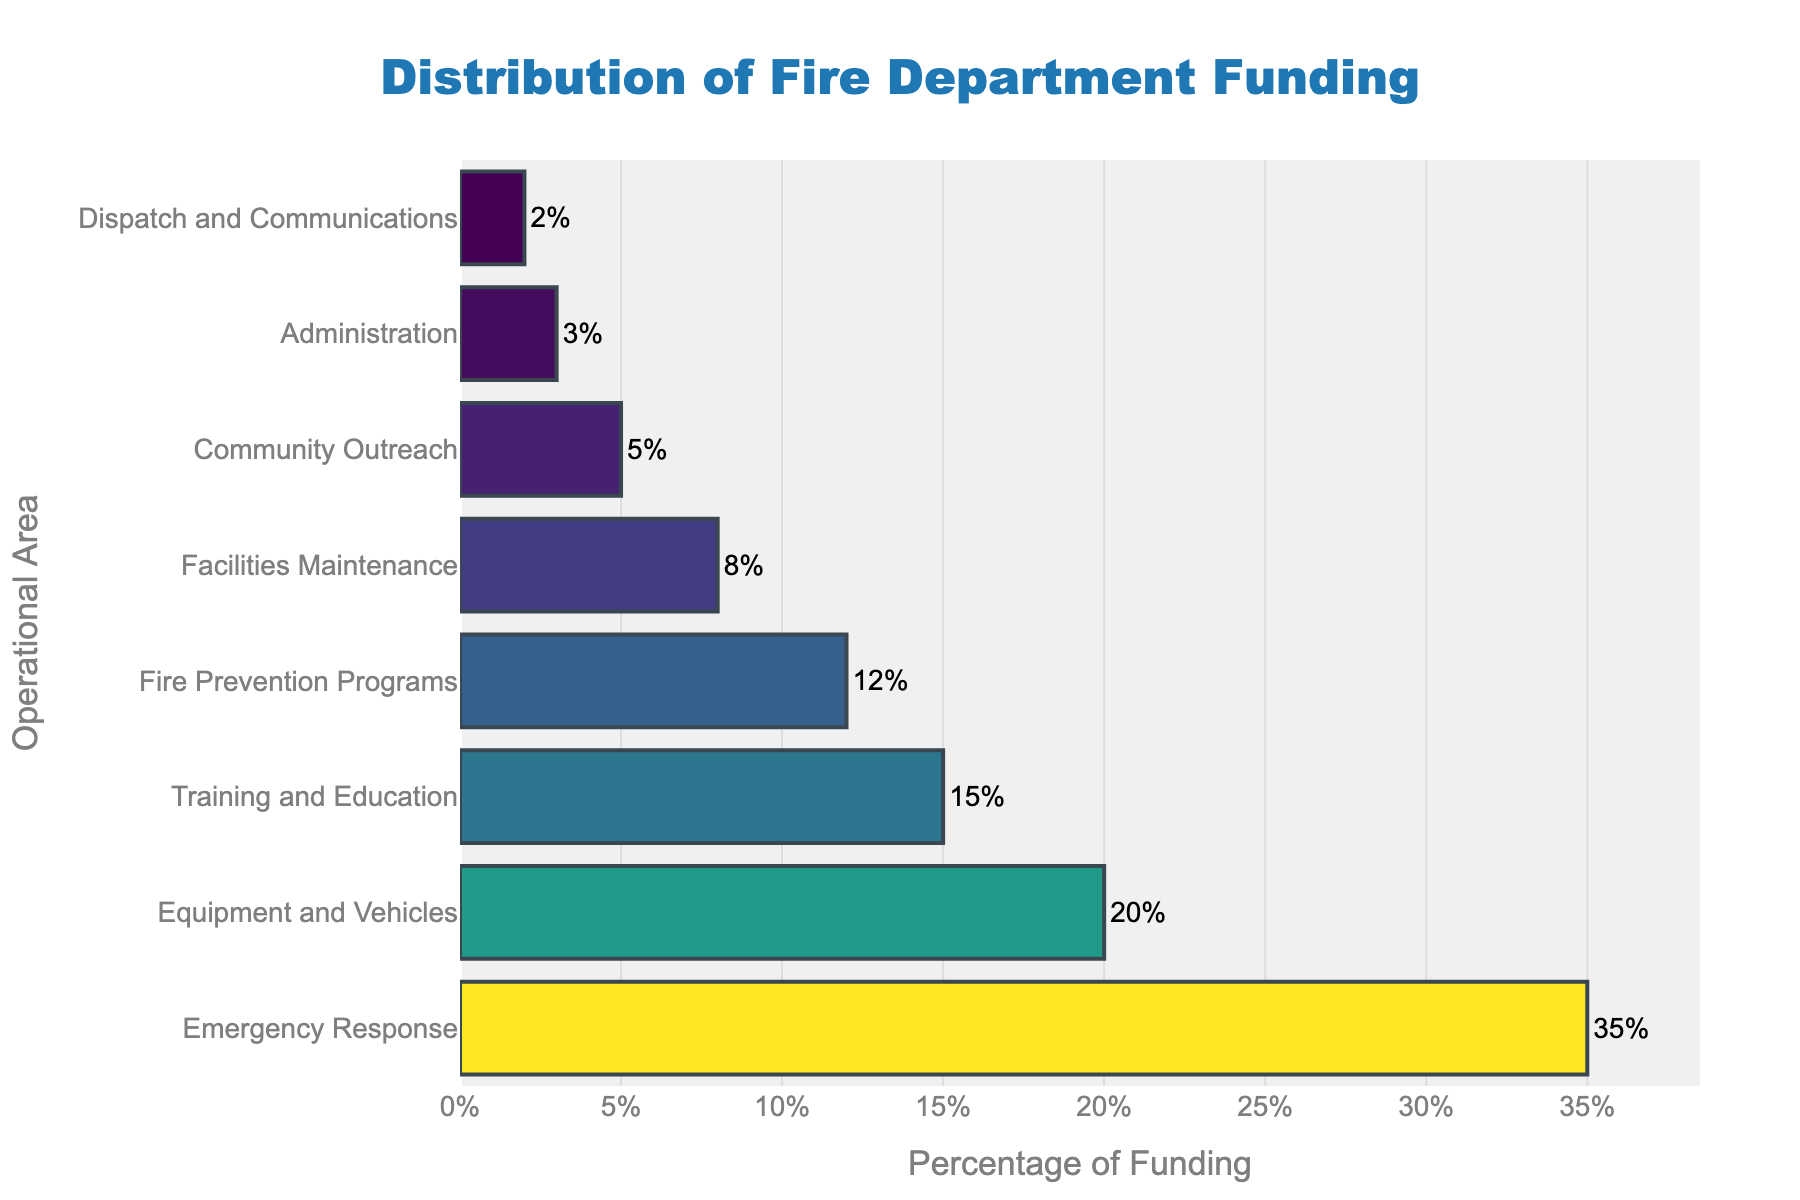Which operational area receives the most funding? The bar for Emergency Response is the longest and shows a percentage of 35%.
Answer: Emergency Response What's the combined percentage of funding for Training and Education and Fire Prevention Programs? The percentage for Training and Education is 15% and for Fire Prevention Programs is 12%. Adding these together gives 15% + 12% = 27%.
Answer: 27% How does the funding for Equipment and Vehicles compare to Facilities Maintenance? The bar for Equipment and Vehicles is longer than the bar for Facilities Maintenance. The percentage for Equipment and Vehicles is 20%, whereas it is 8% for Facilities Maintenance.
Answer: Equipment and Vehicles receives more funding Which operational area has the least funding, and what is its percentage? The shortest bar represents Dispatch and Communications, which has a percentage of 2%.
Answer: Dispatch and Communications, 2% Is the percentage of funding for Community Outreach greater than or equal to that for Administration? The percentage of funding for Community Outreach is 5%, which is greater than the 3% for Administration.
Answer: Yes What’s the difference in funding percentage between Emergency Response and Community Outreach? The percentage for Emergency Response is 35% and for Community Outreach is 5%. The difference is 35% - 5% = 30%.
Answer: 30% What is the average percentage of funding for the areas that receive at least 10% of the funding? The areas are: Emergency Response (35%), Equipment and Vehicles (20%), Training and Education (15%), and Fire Prevention Programs (12%). The sum is 35% + 20% + 15% + 12% = 82%. There are 4 areas, so the average is 82% / 4 = 20.5%.
Answer: 20.5% Does the sum of the percentages for Facilities Maintenance and Administration equal the percentage for Training and Education? Facilities Maintenance is 8% and Administration is 3%. The sum is 8% + 3% = 11%, which is less than the 15% for Training and Education.
Answer: No Which area has a lower percentage of funding – Community Outreach or Dispatch and Communications? Comparing the percentages, Community Outreach has 5% and Dispatch and Communications has 2%.
Answer: Dispatch and Communications What is the total percentage of funding allocated to operational areas receiving less than 10% each? The areas are: Facilities Maintenance (8%), Community Outreach (5%), Administration (3%), and Dispatch and Communications (2%). The sum is 8% + 5% + 3% + 2% = 18%.
Answer: 18% 